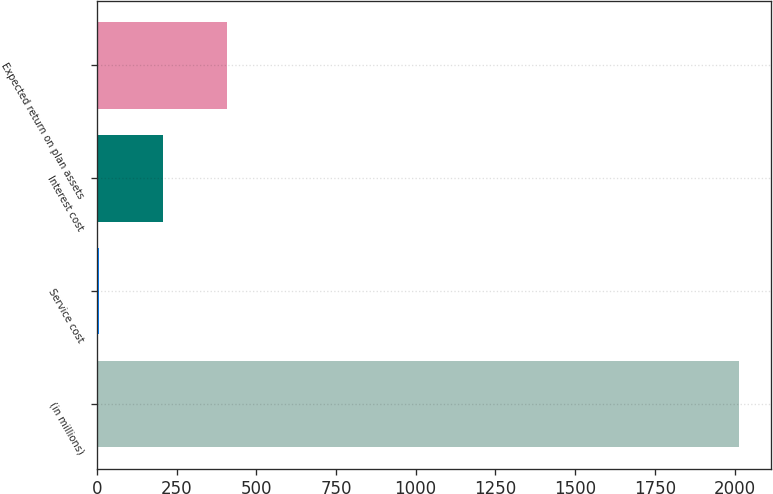Convert chart. <chart><loc_0><loc_0><loc_500><loc_500><bar_chart><fcel>(in millions)<fcel>Service cost<fcel>Interest cost<fcel>Expected return on plan assets<nl><fcel>2014<fcel>7<fcel>207.7<fcel>408.4<nl></chart> 